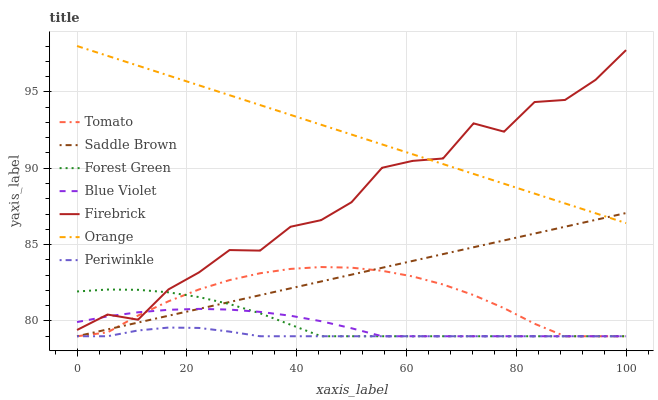Does Periwinkle have the minimum area under the curve?
Answer yes or no. Yes. Does Orange have the maximum area under the curve?
Answer yes or no. Yes. Does Firebrick have the minimum area under the curve?
Answer yes or no. No. Does Firebrick have the maximum area under the curve?
Answer yes or no. No. Is Saddle Brown the smoothest?
Answer yes or no. Yes. Is Firebrick the roughest?
Answer yes or no. Yes. Is Forest Green the smoothest?
Answer yes or no. No. Is Forest Green the roughest?
Answer yes or no. No. Does Tomato have the lowest value?
Answer yes or no. Yes. Does Firebrick have the lowest value?
Answer yes or no. No. Does Orange have the highest value?
Answer yes or no. Yes. Does Firebrick have the highest value?
Answer yes or no. No. Is Blue Violet less than Orange?
Answer yes or no. Yes. Is Firebrick greater than Periwinkle?
Answer yes or no. Yes. Does Blue Violet intersect Tomato?
Answer yes or no. Yes. Is Blue Violet less than Tomato?
Answer yes or no. No. Is Blue Violet greater than Tomato?
Answer yes or no. No. Does Blue Violet intersect Orange?
Answer yes or no. No. 